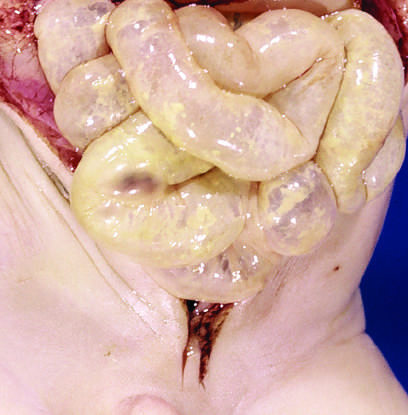does atrophy imply impending perforation?
Answer the question using a single word or phrase. No 